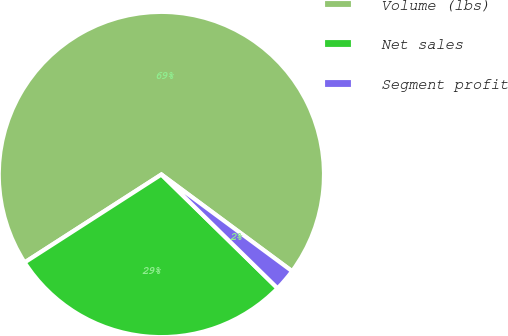<chart> <loc_0><loc_0><loc_500><loc_500><pie_chart><fcel>Volume (lbs)<fcel>Net sales<fcel>Segment profit<nl><fcel>69.23%<fcel>28.57%<fcel>2.2%<nl></chart> 